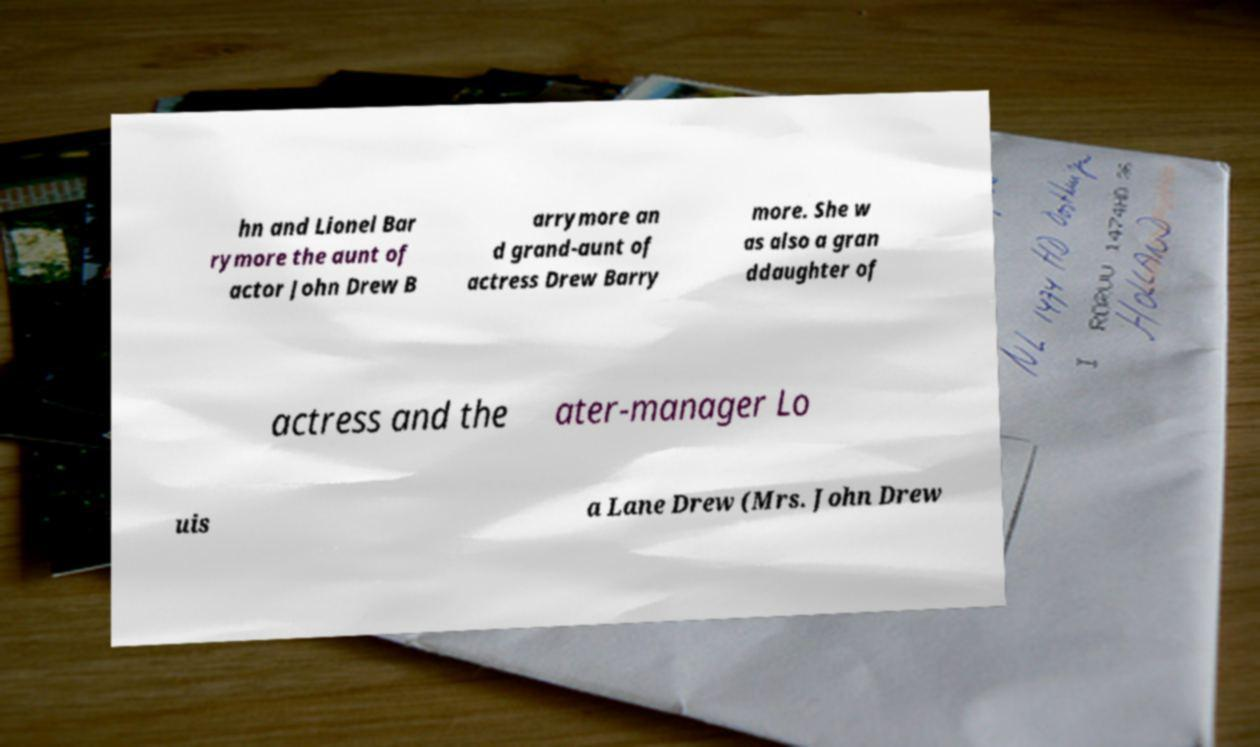Please read and relay the text visible in this image. What does it say? hn and Lionel Bar rymore the aunt of actor John Drew B arrymore an d grand-aunt of actress Drew Barry more. She w as also a gran ddaughter of actress and the ater-manager Lo uis a Lane Drew (Mrs. John Drew 